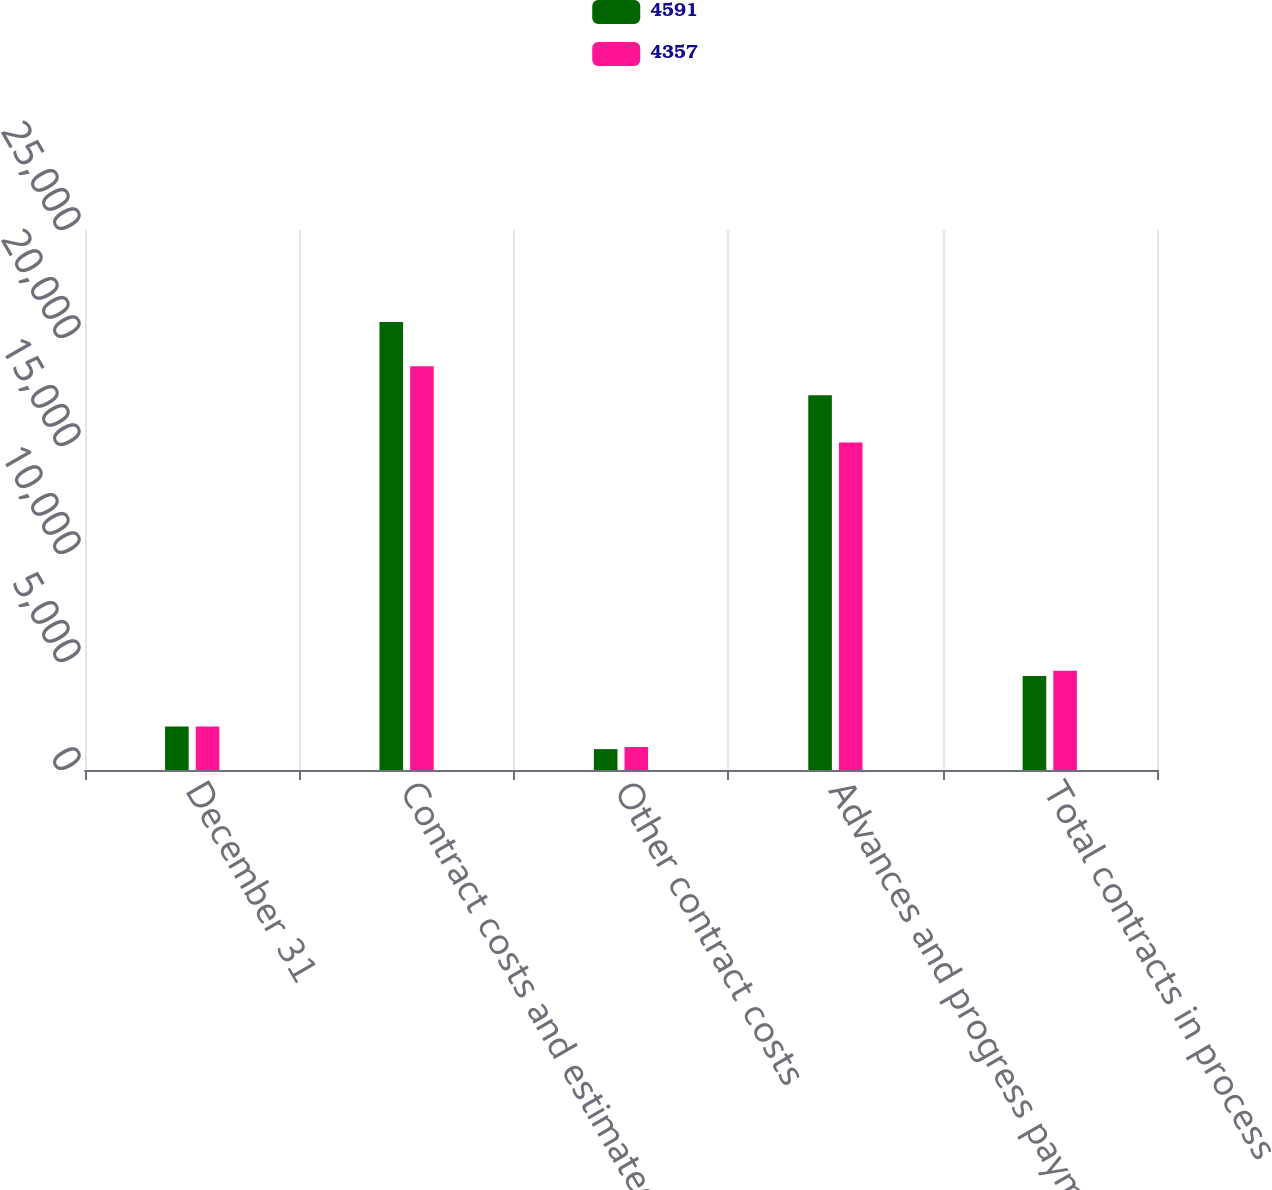<chart> <loc_0><loc_0><loc_500><loc_500><stacked_bar_chart><ecel><fcel>December 31<fcel>Contract costs and estimated<fcel>Other contract costs<fcel>Advances and progress payments<fcel>Total contracts in process<nl><fcel>4591<fcel>2015<fcel>20742<fcel>965<fcel>17350<fcel>4357<nl><fcel>4357<fcel>2014<fcel>18691<fcel>1064<fcel>15164<fcel>4591<nl></chart> 